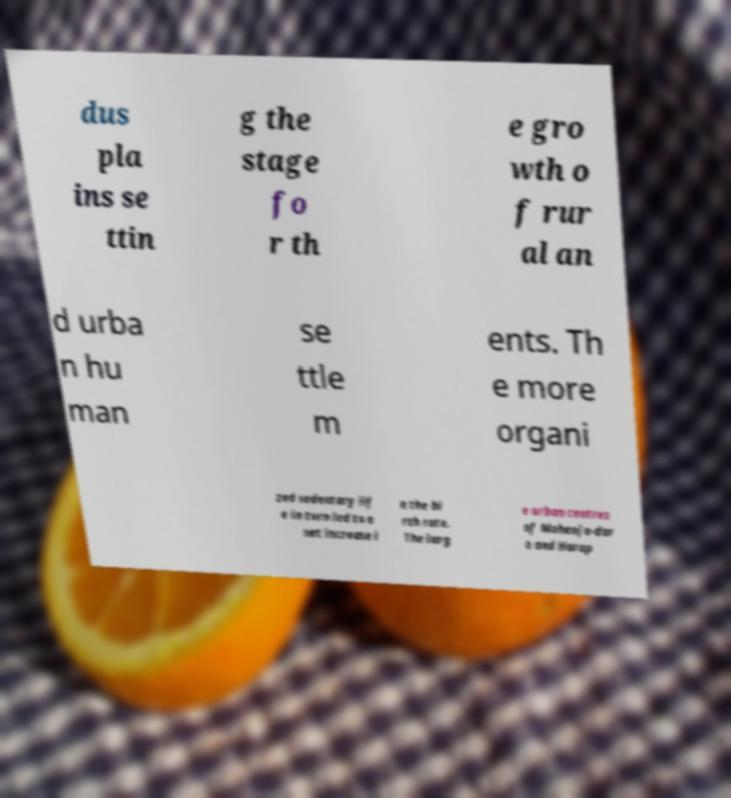Please identify and transcribe the text found in this image. dus pla ins se ttin g the stage fo r th e gro wth o f rur al an d urba n hu man se ttle m ents. Th e more organi zed sedentary lif e in turn led to a net increase i n the bi rth rate. The larg e urban centres of Mohenjo-dar o and Harap 